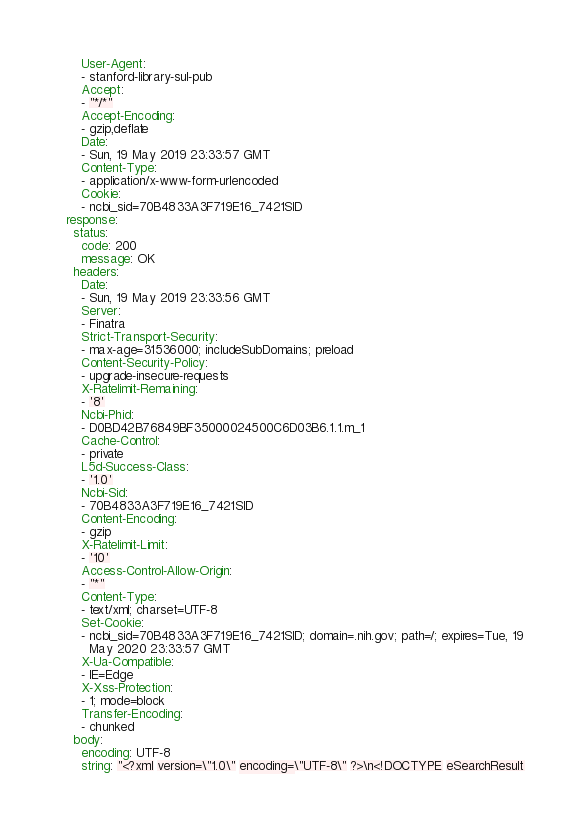Convert code to text. <code><loc_0><loc_0><loc_500><loc_500><_YAML_>      User-Agent:
      - stanford-library-sul-pub
      Accept:
      - "*/*"
      Accept-Encoding:
      - gzip,deflate
      Date:
      - Sun, 19 May 2019 23:33:57 GMT
      Content-Type:
      - application/x-www-form-urlencoded
      Cookie:
      - ncbi_sid=70B4833A3F719E16_7421SID
  response:
    status:
      code: 200
      message: OK
    headers:
      Date:
      - Sun, 19 May 2019 23:33:56 GMT
      Server:
      - Finatra
      Strict-Transport-Security:
      - max-age=31536000; includeSubDomains; preload
      Content-Security-Policy:
      - upgrade-insecure-requests
      X-Ratelimit-Remaining:
      - '8'
      Ncbi-Phid:
      - D0BD42B76849BF35000024500C6D03B6.1.1.m_1
      Cache-Control:
      - private
      L5d-Success-Class:
      - '1.0'
      Ncbi-Sid:
      - 70B4833A3F719E16_7421SID
      Content-Encoding:
      - gzip
      X-Ratelimit-Limit:
      - '10'
      Access-Control-Allow-Origin:
      - "*"
      Content-Type:
      - text/xml; charset=UTF-8
      Set-Cookie:
      - ncbi_sid=70B4833A3F719E16_7421SID; domain=.nih.gov; path=/; expires=Tue, 19
        May 2020 23:33:57 GMT
      X-Ua-Compatible:
      - IE=Edge
      X-Xss-Protection:
      - 1; mode=block
      Transfer-Encoding:
      - chunked
    body:
      encoding: UTF-8
      string: "<?xml version=\"1.0\" encoding=\"UTF-8\" ?>\n<!DOCTYPE eSearchResult</code> 